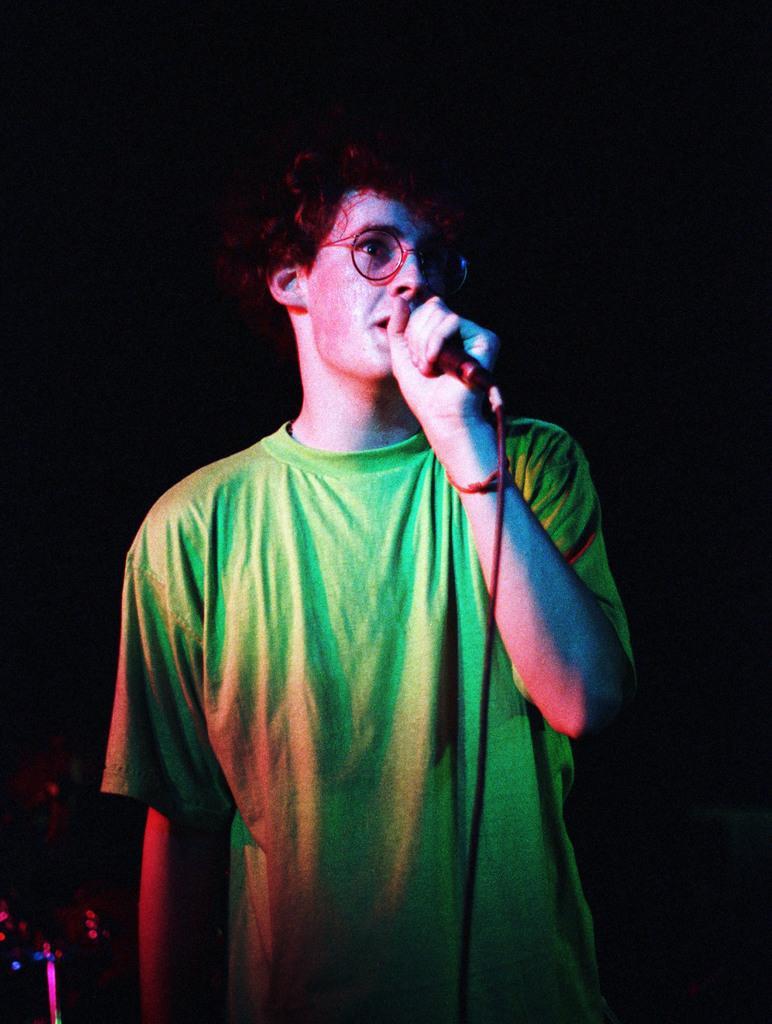Describe this image in one or two sentences. In this picture we can see a person holding a mike and looking at someone. 